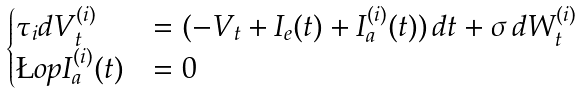<formula> <loc_0><loc_0><loc_500><loc_500>\begin{cases} \tau _ { i } d V _ { t } ^ { ( i ) } & = ( - V _ { t } + I _ { e } ( t ) + I _ { a } ^ { ( i ) } ( t ) ) \, d t + \sigma \, d W ^ { ( i ) } _ { t } \\ \L o p I _ { a } ^ { ( i ) } ( t ) & = 0 \end{cases}</formula> 